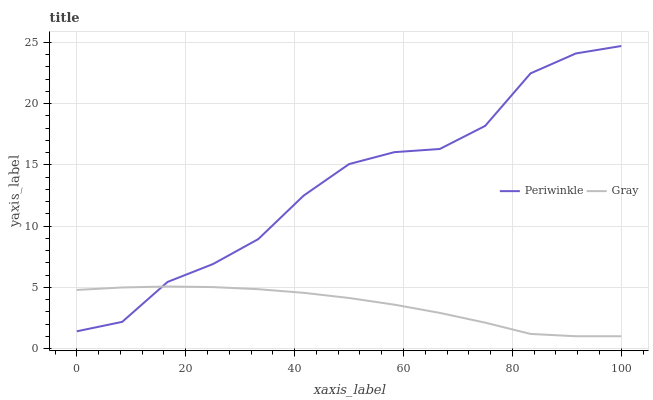Does Gray have the minimum area under the curve?
Answer yes or no. Yes. Does Periwinkle have the maximum area under the curve?
Answer yes or no. Yes. Does Periwinkle have the minimum area under the curve?
Answer yes or no. No. Is Gray the smoothest?
Answer yes or no. Yes. Is Periwinkle the roughest?
Answer yes or no. Yes. Is Periwinkle the smoothest?
Answer yes or no. No. Does Gray have the lowest value?
Answer yes or no. Yes. Does Periwinkle have the lowest value?
Answer yes or no. No. Does Periwinkle have the highest value?
Answer yes or no. Yes. Does Periwinkle intersect Gray?
Answer yes or no. Yes. Is Periwinkle less than Gray?
Answer yes or no. No. Is Periwinkle greater than Gray?
Answer yes or no. No. 